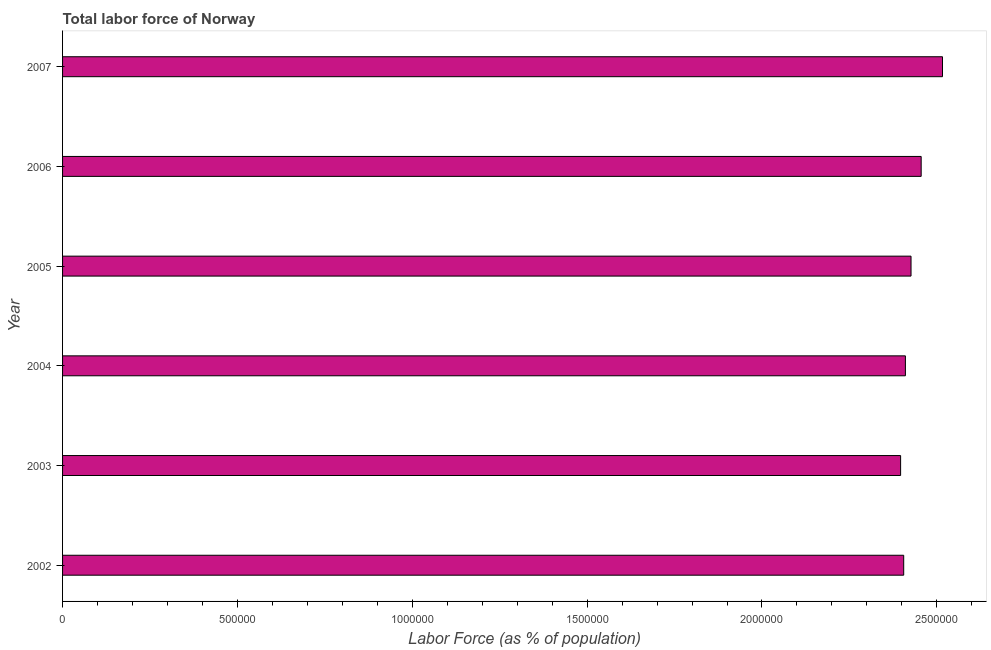What is the title of the graph?
Ensure brevity in your answer.  Total labor force of Norway. What is the label or title of the X-axis?
Ensure brevity in your answer.  Labor Force (as % of population). What is the total labor force in 2005?
Provide a succinct answer. 2.43e+06. Across all years, what is the maximum total labor force?
Your answer should be compact. 2.52e+06. Across all years, what is the minimum total labor force?
Provide a succinct answer. 2.40e+06. In which year was the total labor force maximum?
Your answer should be very brief. 2007. In which year was the total labor force minimum?
Provide a succinct answer. 2003. What is the sum of the total labor force?
Your answer should be very brief. 1.46e+07. What is the difference between the total labor force in 2004 and 2005?
Make the answer very short. -1.61e+04. What is the average total labor force per year?
Ensure brevity in your answer.  2.43e+06. What is the median total labor force?
Provide a short and direct response. 2.42e+06. Is the total labor force in 2006 less than that in 2007?
Offer a very short reply. Yes. Is the difference between the total labor force in 2004 and 2007 greater than the difference between any two years?
Give a very brief answer. No. What is the difference between the highest and the second highest total labor force?
Make the answer very short. 6.10e+04. What is the difference between the highest and the lowest total labor force?
Give a very brief answer. 1.20e+05. How many years are there in the graph?
Provide a short and direct response. 6. What is the difference between two consecutive major ticks on the X-axis?
Ensure brevity in your answer.  5.00e+05. Are the values on the major ticks of X-axis written in scientific E-notation?
Your response must be concise. No. What is the Labor Force (as % of population) in 2002?
Your answer should be very brief. 2.41e+06. What is the Labor Force (as % of population) in 2003?
Keep it short and to the point. 2.40e+06. What is the Labor Force (as % of population) of 2004?
Your response must be concise. 2.41e+06. What is the Labor Force (as % of population) in 2005?
Offer a very short reply. 2.43e+06. What is the Labor Force (as % of population) in 2006?
Give a very brief answer. 2.46e+06. What is the Labor Force (as % of population) in 2007?
Offer a terse response. 2.52e+06. What is the difference between the Labor Force (as % of population) in 2002 and 2003?
Ensure brevity in your answer.  8875. What is the difference between the Labor Force (as % of population) in 2002 and 2004?
Give a very brief answer. -4829. What is the difference between the Labor Force (as % of population) in 2002 and 2005?
Your answer should be compact. -2.09e+04. What is the difference between the Labor Force (as % of population) in 2002 and 2006?
Offer a terse response. -4.99e+04. What is the difference between the Labor Force (as % of population) in 2002 and 2007?
Offer a terse response. -1.11e+05. What is the difference between the Labor Force (as % of population) in 2003 and 2004?
Provide a short and direct response. -1.37e+04. What is the difference between the Labor Force (as % of population) in 2003 and 2005?
Your answer should be very brief. -2.98e+04. What is the difference between the Labor Force (as % of population) in 2003 and 2006?
Provide a short and direct response. -5.88e+04. What is the difference between the Labor Force (as % of population) in 2003 and 2007?
Your response must be concise. -1.20e+05. What is the difference between the Labor Force (as % of population) in 2004 and 2005?
Keep it short and to the point. -1.61e+04. What is the difference between the Labor Force (as % of population) in 2004 and 2006?
Keep it short and to the point. -4.51e+04. What is the difference between the Labor Force (as % of population) in 2004 and 2007?
Your answer should be compact. -1.06e+05. What is the difference between the Labor Force (as % of population) in 2005 and 2006?
Offer a very short reply. -2.90e+04. What is the difference between the Labor Force (as % of population) in 2005 and 2007?
Offer a terse response. -9.00e+04. What is the difference between the Labor Force (as % of population) in 2006 and 2007?
Your answer should be compact. -6.10e+04. What is the ratio of the Labor Force (as % of population) in 2002 to that in 2004?
Your response must be concise. 1. What is the ratio of the Labor Force (as % of population) in 2002 to that in 2007?
Give a very brief answer. 0.96. What is the ratio of the Labor Force (as % of population) in 2003 to that in 2006?
Give a very brief answer. 0.98. What is the ratio of the Labor Force (as % of population) in 2003 to that in 2007?
Offer a terse response. 0.95. What is the ratio of the Labor Force (as % of population) in 2004 to that in 2006?
Keep it short and to the point. 0.98. What is the ratio of the Labor Force (as % of population) in 2004 to that in 2007?
Provide a short and direct response. 0.96. What is the ratio of the Labor Force (as % of population) in 2006 to that in 2007?
Make the answer very short. 0.98. 